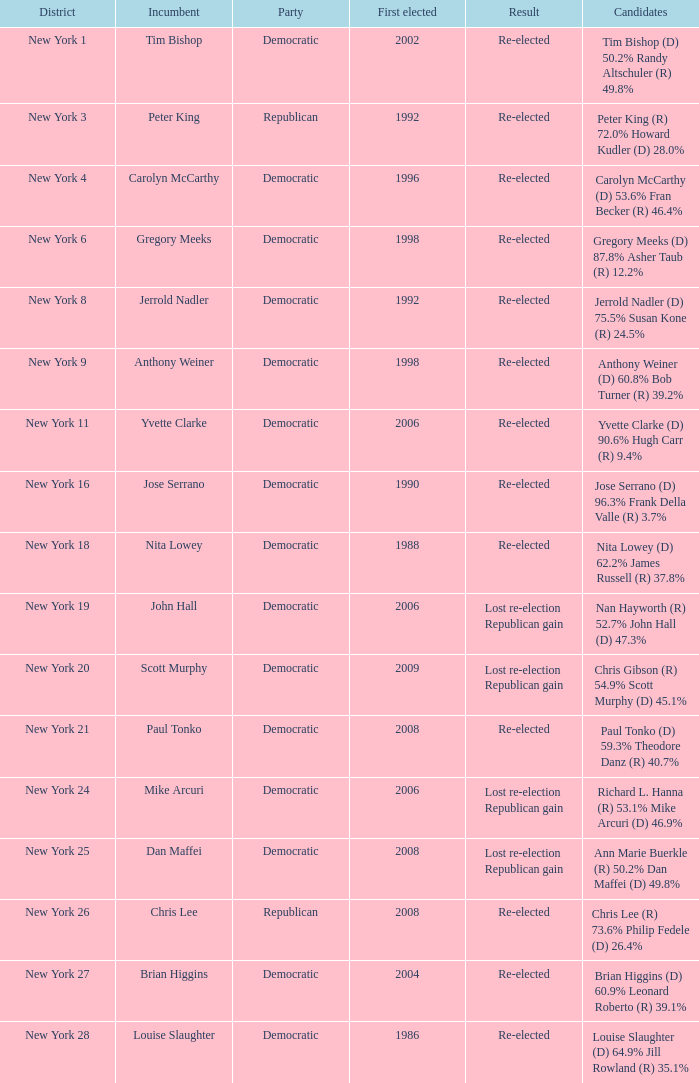Name the result for new york 8 Re-elected. 